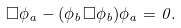<formula> <loc_0><loc_0><loc_500><loc_500>\Box \phi _ { a } - ( \phi _ { b } \Box \phi _ { b } ) \phi _ { a } = 0 .</formula> 